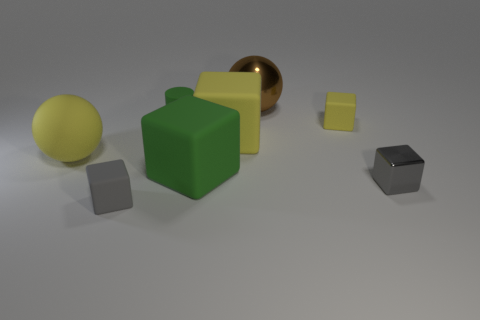There is a tiny matte block behind the gray rubber thing; what is its color?
Offer a very short reply. Yellow. There is a yellow matte thing that is the same shape as the brown thing; what size is it?
Give a very brief answer. Large. What number of objects are either tiny gray cubes that are in front of the small metal cube or objects in front of the big yellow sphere?
Your response must be concise. 3. How big is the thing that is behind the big yellow matte block and to the left of the large metal sphere?
Provide a short and direct response. Small. Is the shape of the big green matte thing the same as the small thing that is in front of the tiny metallic thing?
Ensure brevity in your answer.  Yes. What number of objects are either yellow matte objects that are right of the tiny green matte thing or green rubber cylinders?
Your answer should be compact. 3. Is the material of the big green cube the same as the gray object that is on the right side of the big brown metallic ball?
Offer a terse response. No. The green thing behind the big ball in front of the large brown metal sphere is what shape?
Give a very brief answer. Cylinder. Is the color of the cylinder the same as the large object in front of the yellow ball?
Offer a very short reply. Yes. What is the shape of the small gray metal object?
Offer a very short reply. Cube. 